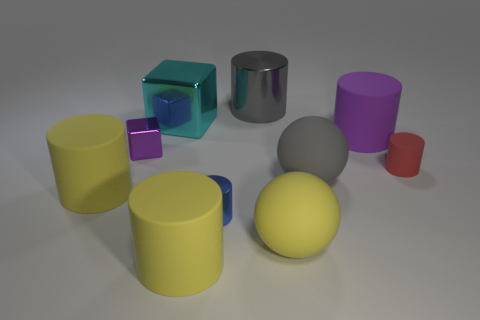The gray cylinder that is the same material as the blue object is what size?
Keep it short and to the point. Large. How many small balls have the same color as the big metallic cylinder?
Ensure brevity in your answer.  0. Are there fewer purple metallic objects behind the cyan object than large spheres behind the yellow rubber sphere?
Keep it short and to the point. Yes. There is a purple object that is behind the tiny block; is it the same shape as the small red matte object?
Your answer should be very brief. Yes. Are there any other things that have the same material as the tiny blue cylinder?
Ensure brevity in your answer.  Yes. Is the tiny cylinder that is right of the purple cylinder made of the same material as the gray ball?
Make the answer very short. Yes. What is the material of the tiny cylinder that is left of the big gray thing behind the cube that is to the left of the big cyan block?
Ensure brevity in your answer.  Metal. What number of other things are the same shape as the gray metal thing?
Your answer should be compact. 5. The tiny cylinder right of the large purple rubber object is what color?
Give a very brief answer. Red. How many yellow rubber things are in front of the blue metallic thing left of the big gray thing that is in front of the tiny purple thing?
Provide a short and direct response. 2. 